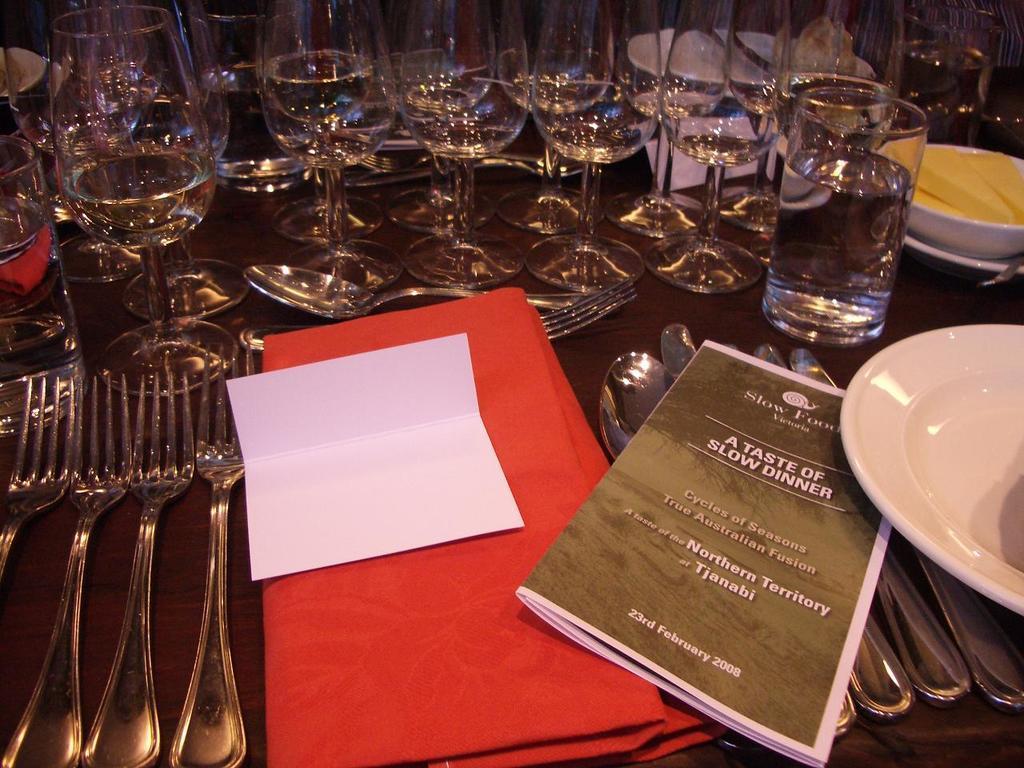How would you summarize this image in a sentence or two? In the picture we can see a part of the table with few glasses, forks, spoons, red color cloth, part of the plate and a magazine near it. 